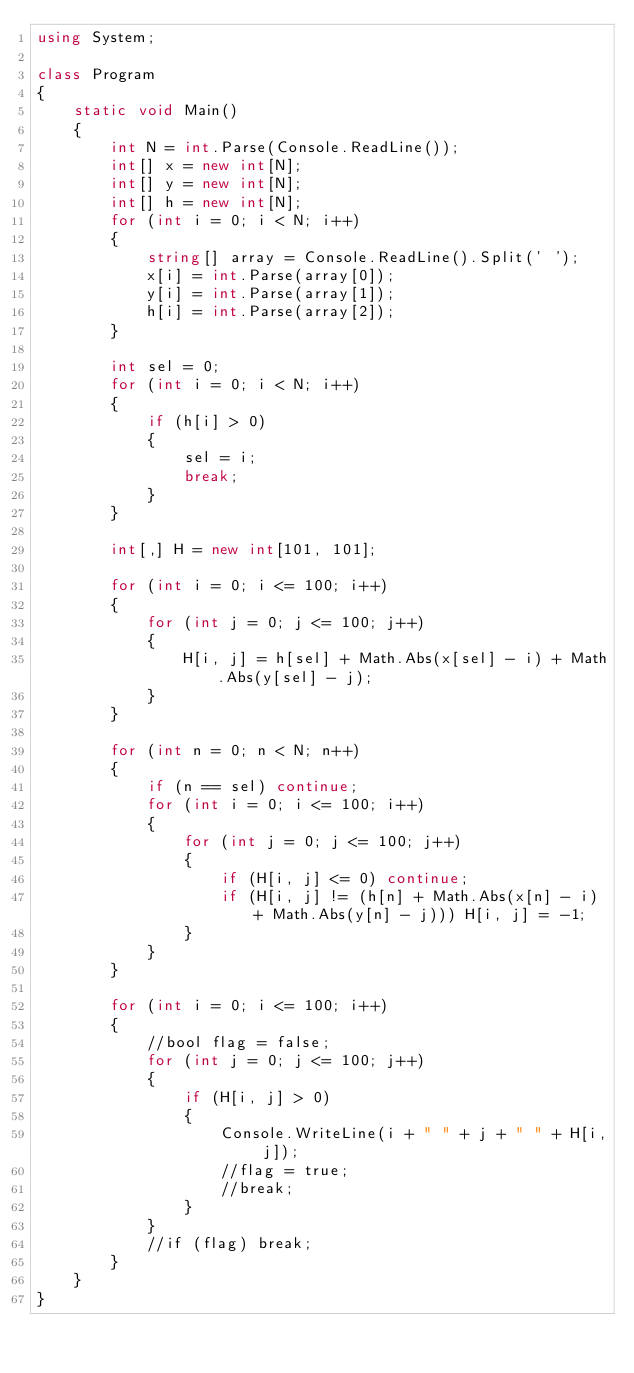Convert code to text. <code><loc_0><loc_0><loc_500><loc_500><_C#_>using System;

class Program
{
    static void Main()
    {
        int N = int.Parse(Console.ReadLine());
        int[] x = new int[N];
        int[] y = new int[N];
        int[] h = new int[N];
        for (int i = 0; i < N; i++)
        {
            string[] array = Console.ReadLine().Split(' ');
            x[i] = int.Parse(array[0]);
            y[i] = int.Parse(array[1]);
            h[i] = int.Parse(array[2]);
        }

        int sel = 0;
        for (int i = 0; i < N; i++)
        {
            if (h[i] > 0)
            {
                sel = i;
                break;
            }
        }

        int[,] H = new int[101, 101];

        for (int i = 0; i <= 100; i++)
        {
            for (int j = 0; j <= 100; j++)
            {
                H[i, j] = h[sel] + Math.Abs(x[sel] - i) + Math.Abs(y[sel] - j);
            }
        }

        for (int n = 0; n < N; n++)
        {
            if (n == sel) continue;
            for (int i = 0; i <= 100; i++)
            {
                for (int j = 0; j <= 100; j++)
                {
                    if (H[i, j] <= 0) continue;
                    if (H[i, j] != (h[n] + Math.Abs(x[n] - i) + Math.Abs(y[n] - j))) H[i, j] = -1;
                }
            }
        }

        for (int i = 0; i <= 100; i++)
        {
            //bool flag = false;
            for (int j = 0; j <= 100; j++)
            {
                if (H[i, j] > 0)
                {
                    Console.WriteLine(i + " " + j + " " + H[i, j]);
                    //flag = true;
                    //break;
                }
            }
            //if (flag) break;
        }
    }
}</code> 